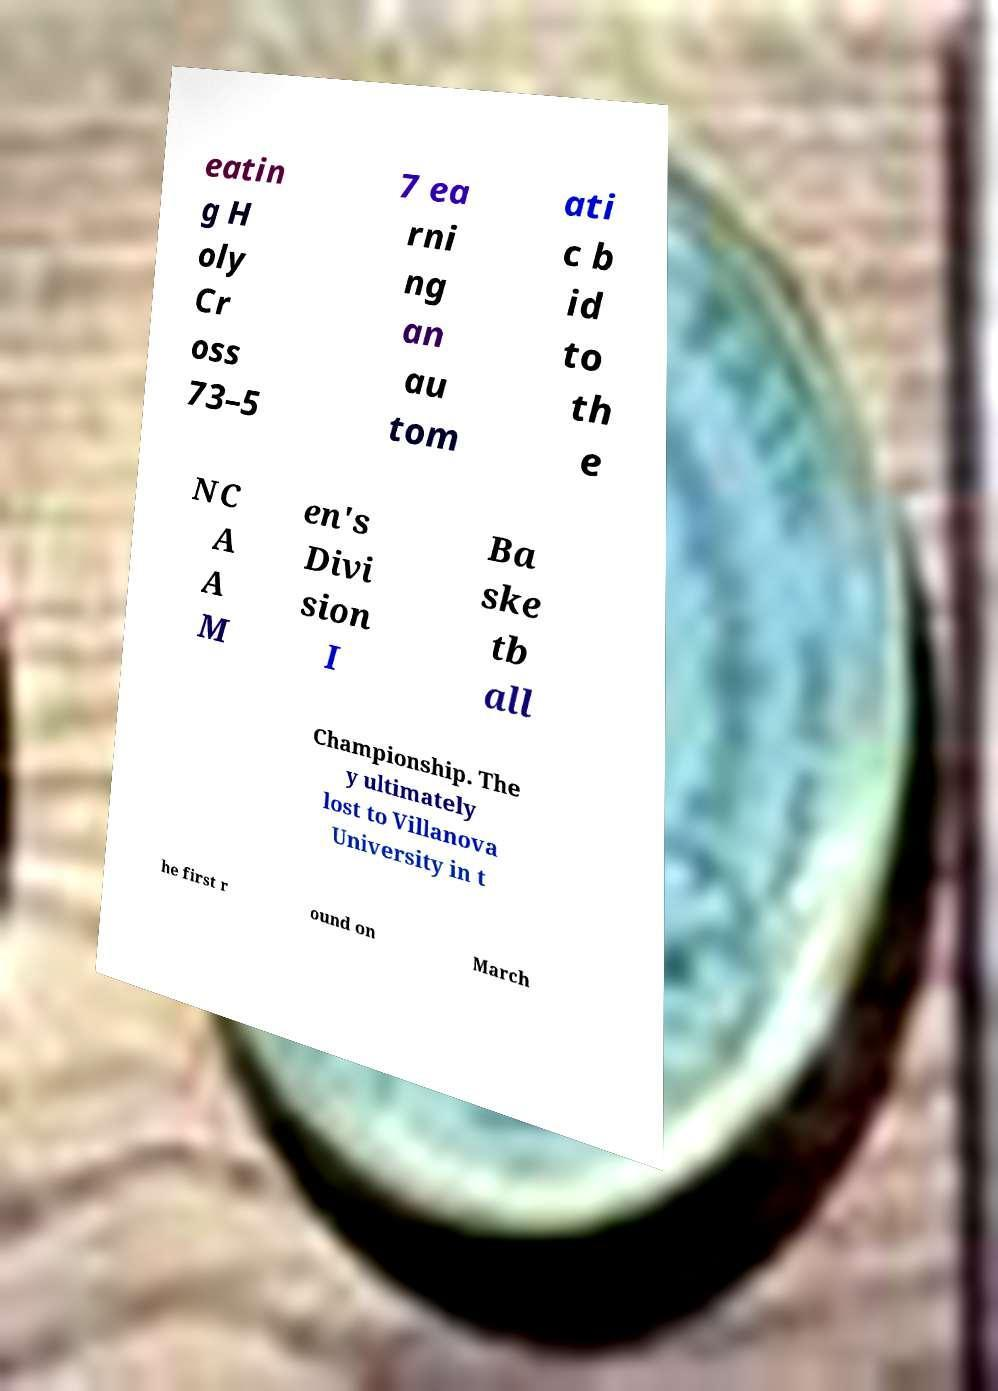Please identify and transcribe the text found in this image. eatin g H oly Cr oss 73–5 7 ea rni ng an au tom ati c b id to th e NC A A M en's Divi sion I Ba ske tb all Championship. The y ultimately lost to Villanova University in t he first r ound on March 